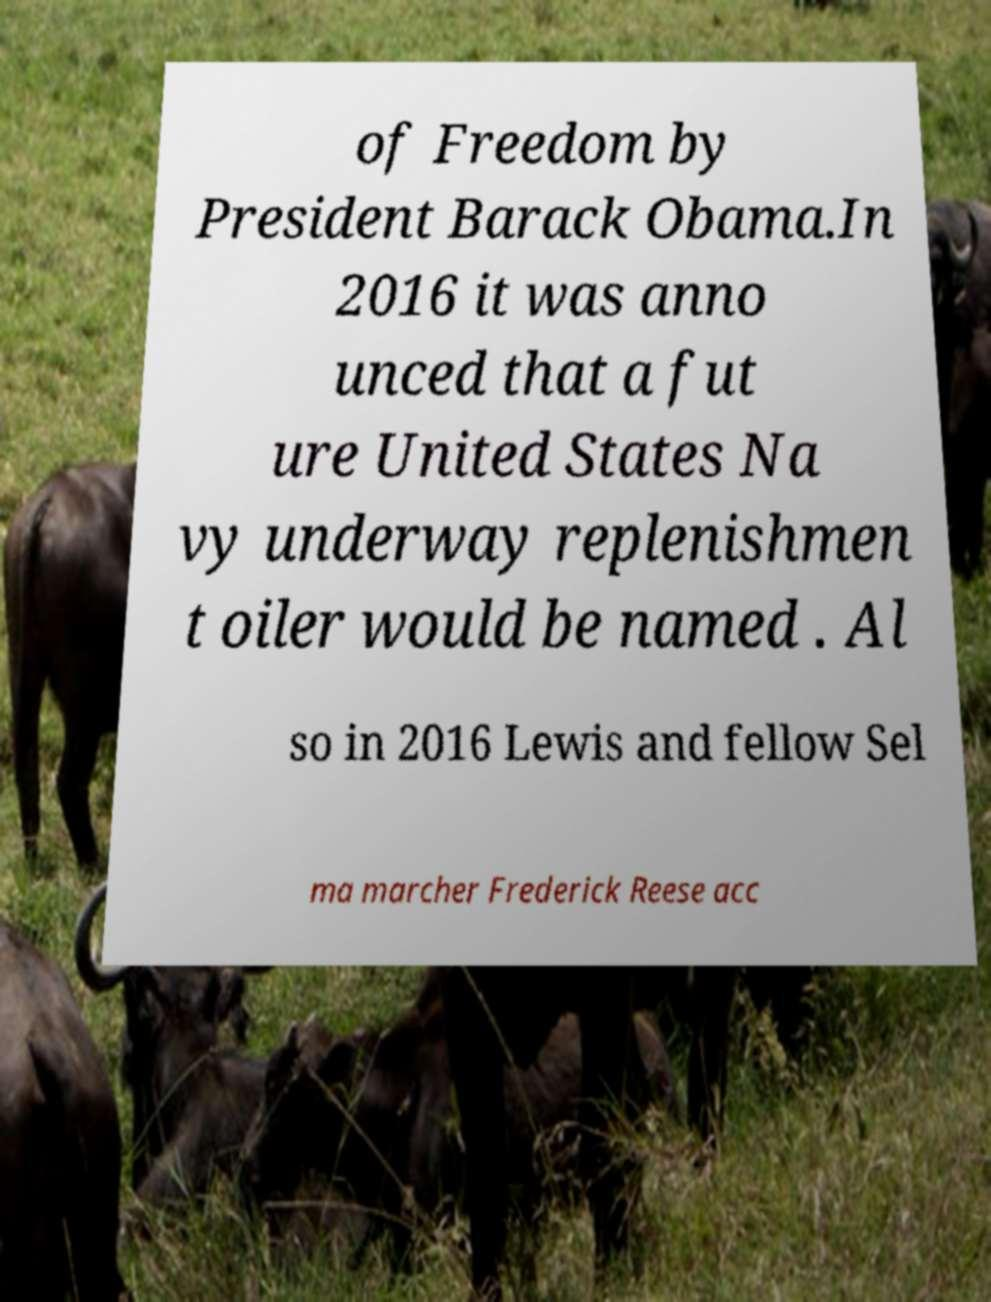Can you read and provide the text displayed in the image?This photo seems to have some interesting text. Can you extract and type it out for me? of Freedom by President Barack Obama.In 2016 it was anno unced that a fut ure United States Na vy underway replenishmen t oiler would be named . Al so in 2016 Lewis and fellow Sel ma marcher Frederick Reese acc 